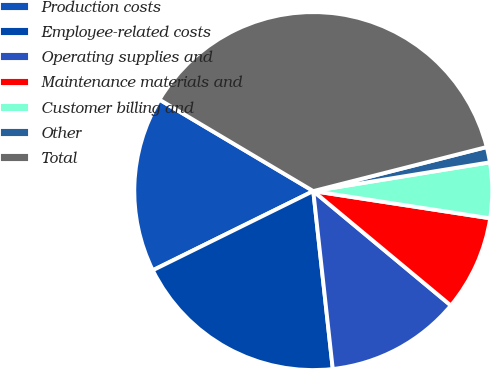Convert chart. <chart><loc_0><loc_0><loc_500><loc_500><pie_chart><fcel>Production costs<fcel>Employee-related costs<fcel>Operating supplies and<fcel>Maintenance materials and<fcel>Customer billing and<fcel>Other<fcel>Total<nl><fcel>15.83%<fcel>19.44%<fcel>12.22%<fcel>8.61%<fcel>5.0%<fcel>1.39%<fcel>37.5%<nl></chart> 